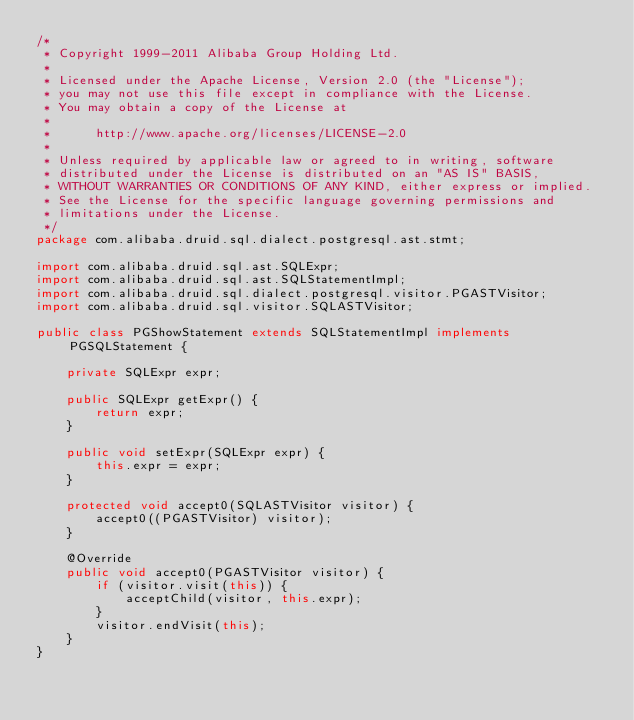<code> <loc_0><loc_0><loc_500><loc_500><_Java_>/*
 * Copyright 1999-2011 Alibaba Group Holding Ltd.
 *
 * Licensed under the Apache License, Version 2.0 (the "License");
 * you may not use this file except in compliance with the License.
 * You may obtain a copy of the License at
 *
 *      http://www.apache.org/licenses/LICENSE-2.0
 *
 * Unless required by applicable law or agreed to in writing, software
 * distributed under the License is distributed on an "AS IS" BASIS,
 * WITHOUT WARRANTIES OR CONDITIONS OF ANY KIND, either express or implied.
 * See the License for the specific language governing permissions and
 * limitations under the License.
 */
package com.alibaba.druid.sql.dialect.postgresql.ast.stmt;

import com.alibaba.druid.sql.ast.SQLExpr;
import com.alibaba.druid.sql.ast.SQLStatementImpl;
import com.alibaba.druid.sql.dialect.postgresql.visitor.PGASTVisitor;
import com.alibaba.druid.sql.visitor.SQLASTVisitor;

public class PGShowStatement extends SQLStatementImpl implements PGSQLStatement {

    private SQLExpr expr;

    public SQLExpr getExpr() {
        return expr;
    }

    public void setExpr(SQLExpr expr) {
        this.expr = expr;
    }

    protected void accept0(SQLASTVisitor visitor) {
        accept0((PGASTVisitor) visitor);
    }

    @Override
    public void accept0(PGASTVisitor visitor) {
        if (visitor.visit(this)) {
            acceptChild(visitor, this.expr);
        }
        visitor.endVisit(this);
    }
}
</code> 